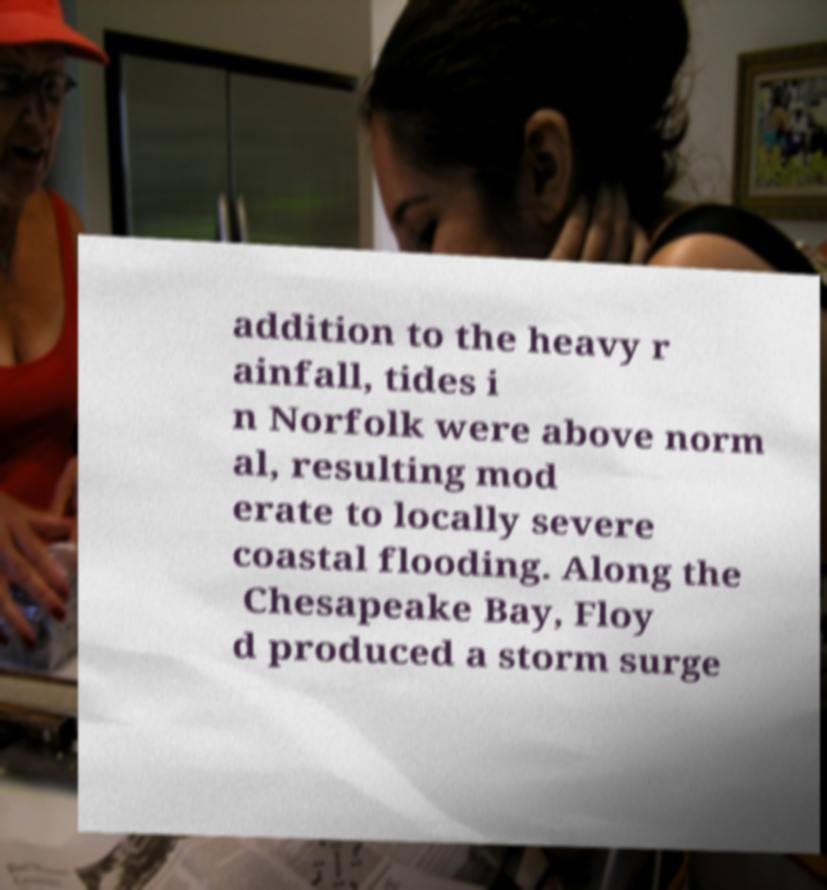Please read and relay the text visible in this image. What does it say? addition to the heavy r ainfall, tides i n Norfolk were above norm al, resulting mod erate to locally severe coastal flooding. Along the Chesapeake Bay, Floy d produced a storm surge 